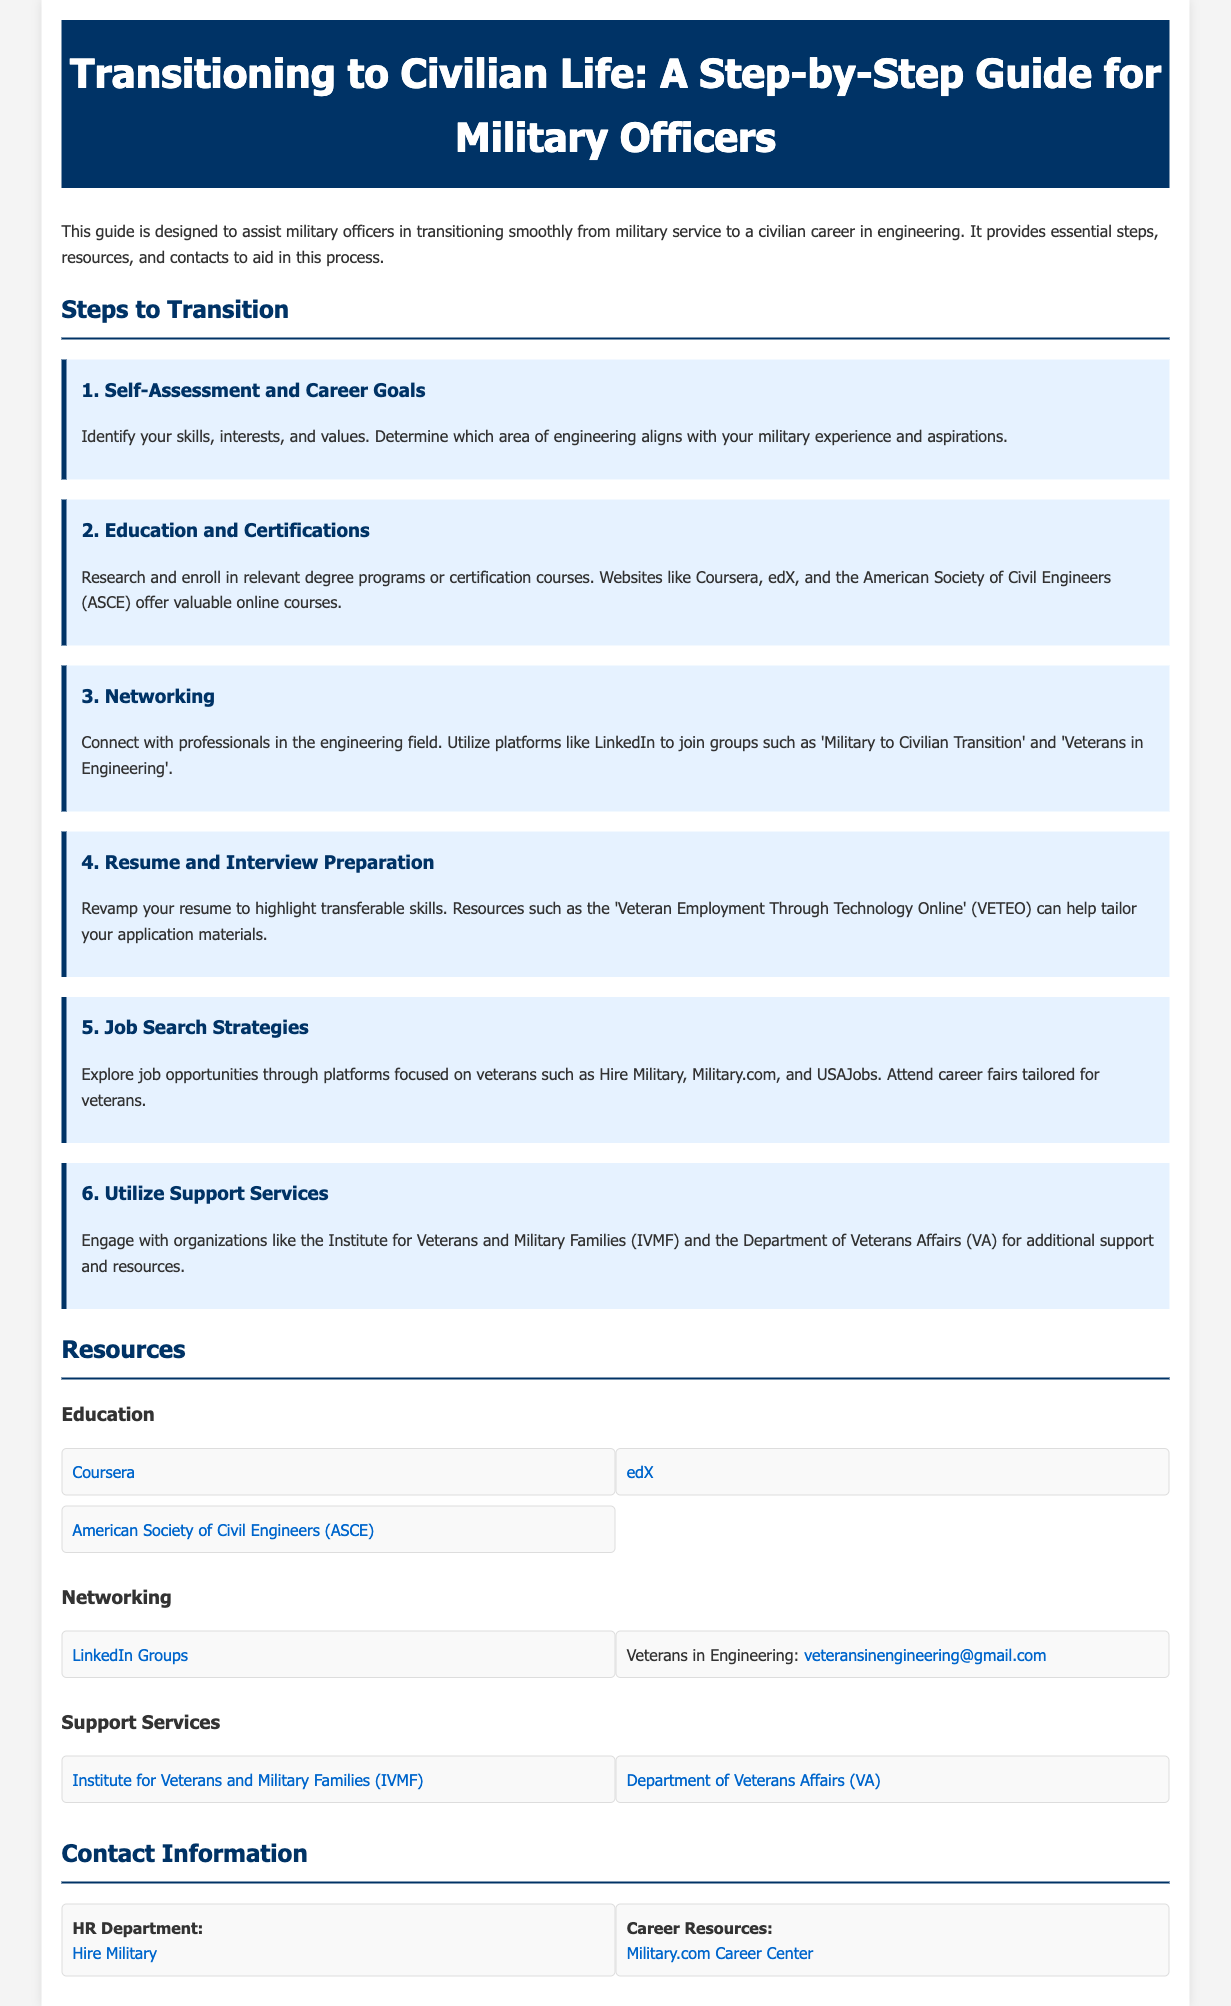What is the main focus of this guide? The main focus of the guide is to assist military officers in transitioning smoothly from military service to a civilian career in engineering.
Answer: transitioning smoothly from military service to a civilian career in engineering How many steps are outlined in the transition process? There are six steps outlined in the transition process detailed in the guide.
Answer: six What is the first step in the transition process? The first step in the transition process is to conduct a self-assessment and define career goals.
Answer: Self-Assessment and Career Goals Which organization offers resources for veterans and military families? The organization mentioned that offers resources is the Institute for Veterans and Military Families (IVMF).
Answer: Institute for Veterans and Military Families (IVMF) What is one online platform mentioned for educational resources? One online platform mentioned for educational resources is Coursera.
Answer: Coursera Which department provides additional support and resources as stated in the document? The Department of Veterans Affairs (VA) is the department that provides additional support and resources.
Answer: Department of Veterans Affairs (VA) Name one network group that military officers can join for networking. One network group that military officers can join for networking is 'Military to Civilian Transition'.
Answer: Military to Civilian Transition What online platform is suggested for job searches specific to veterans? The suggested online platform for job searches specific to veterans is Hire Military.
Answer: Hire Military 